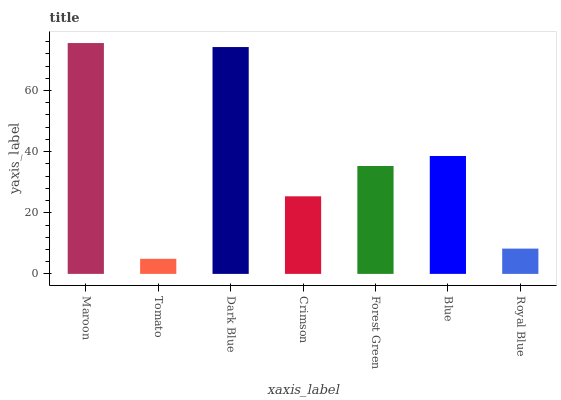Is Dark Blue the minimum?
Answer yes or no. No. Is Dark Blue the maximum?
Answer yes or no. No. Is Dark Blue greater than Tomato?
Answer yes or no. Yes. Is Tomato less than Dark Blue?
Answer yes or no. Yes. Is Tomato greater than Dark Blue?
Answer yes or no. No. Is Dark Blue less than Tomato?
Answer yes or no. No. Is Forest Green the high median?
Answer yes or no. Yes. Is Forest Green the low median?
Answer yes or no. Yes. Is Maroon the high median?
Answer yes or no. No. Is Tomato the low median?
Answer yes or no. No. 